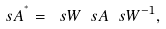<formula> <loc_0><loc_0><loc_500><loc_500>\ s A ^ { ^ { * } } = \ s W \ s A \ s W ^ { - 1 } ,</formula> 